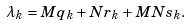<formula> <loc_0><loc_0><loc_500><loc_500>\lambda _ { k } = M q _ { k } + N r _ { k } + M N s _ { k } .</formula> 